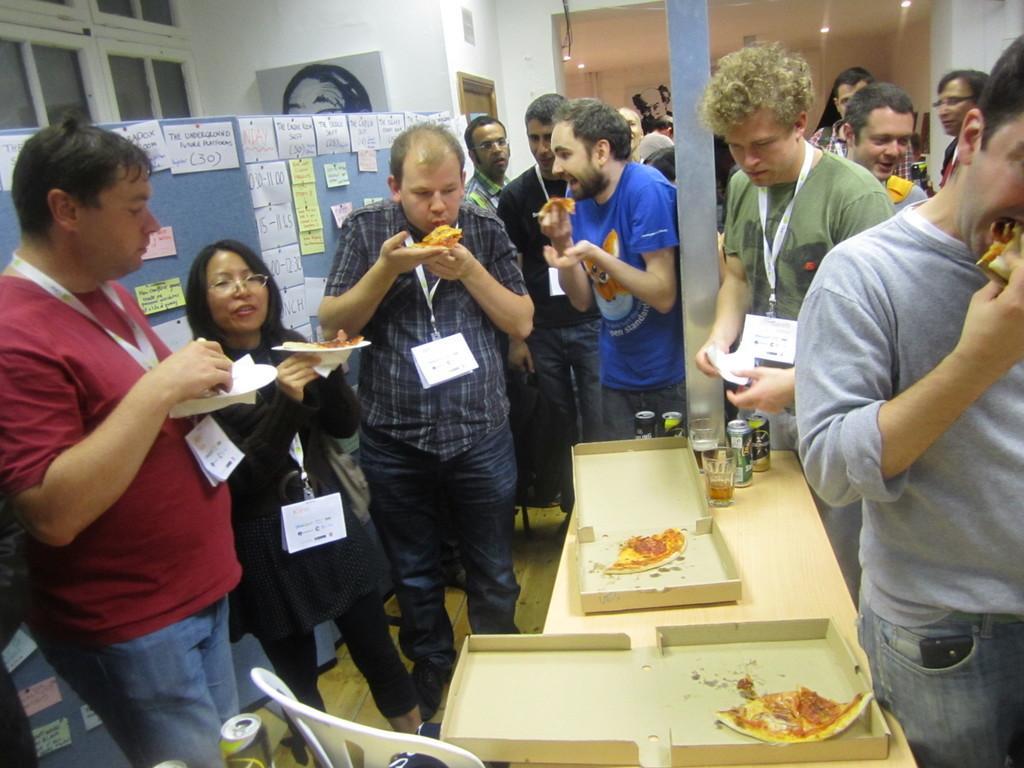In one or two sentences, can you explain what this image depicts? In this picture we can see the group of persons holding pizza and eating it. There is a man who is holding tissue paper and standing near to the table. On the table we can see cotton boxers, pizza pieces, wine glasses, coke cans and other objects. Beside the table we can see the chair. Back side of this person there is a board. At the top we can see the lights. In the top left corner we can see the windows near to the painting. 